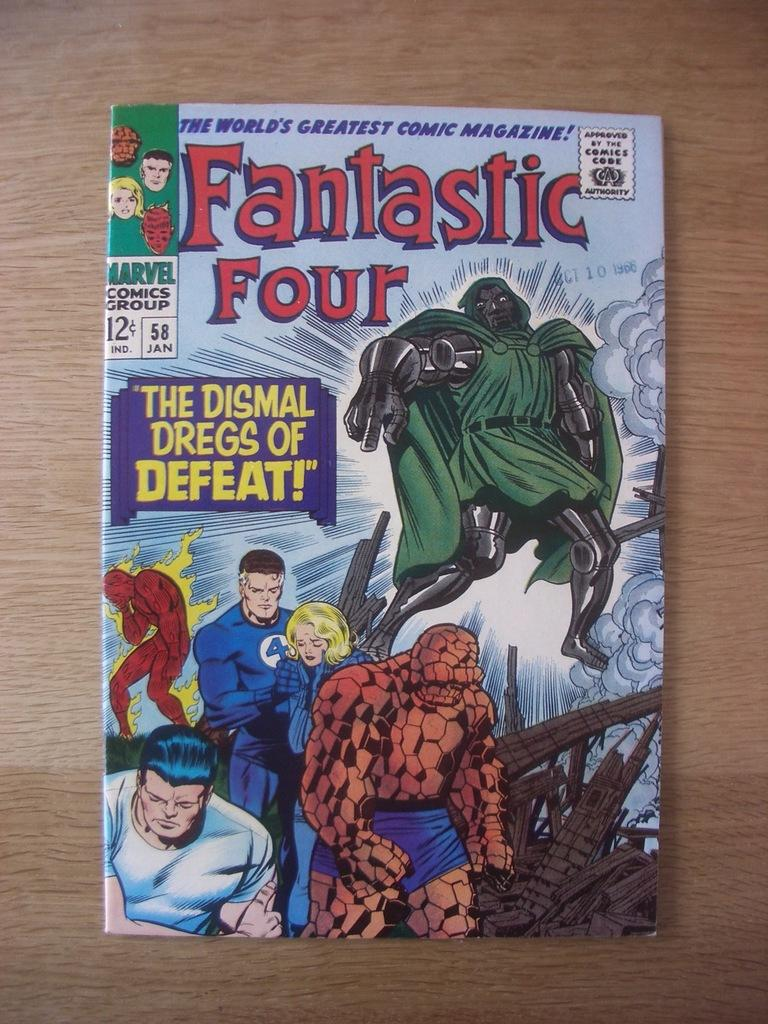Provide a one-sentence caption for the provided image. A Fantastic Four comic called "The Dismal Dregs of Defeat!" lies on a wooden table. 